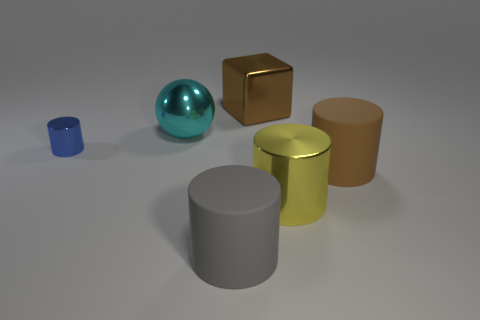Is the size of the metallic cube the same as the metal cylinder left of the brown cube?
Give a very brief answer. No. Is there a rubber cylinder of the same color as the shiny cube?
Offer a very short reply. Yes. What is the size of the cube that is made of the same material as the big cyan object?
Keep it short and to the point. Large. Is the material of the blue cylinder the same as the cyan sphere?
Offer a very short reply. Yes. The large matte cylinder right of the big matte cylinder on the left side of the large cylinder that is behind the big yellow cylinder is what color?
Give a very brief answer. Brown. What is the shape of the small thing?
Offer a terse response. Cylinder. Does the metal block have the same color as the matte cylinder that is behind the gray object?
Provide a succinct answer. Yes. Is the number of cyan objects behind the blue thing the same as the number of tiny purple balls?
Offer a terse response. No. What number of rubber cylinders have the same size as the cyan metallic thing?
Keep it short and to the point. 2. There is a large thing that is the same color as the large metallic cube; what shape is it?
Your answer should be compact. Cylinder. 